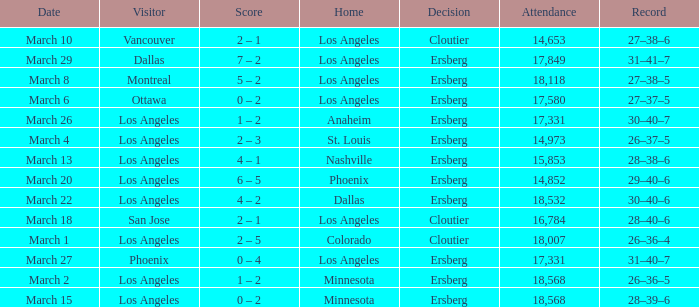What is the Decision listed when the Home was Colorado? Cloutier. 